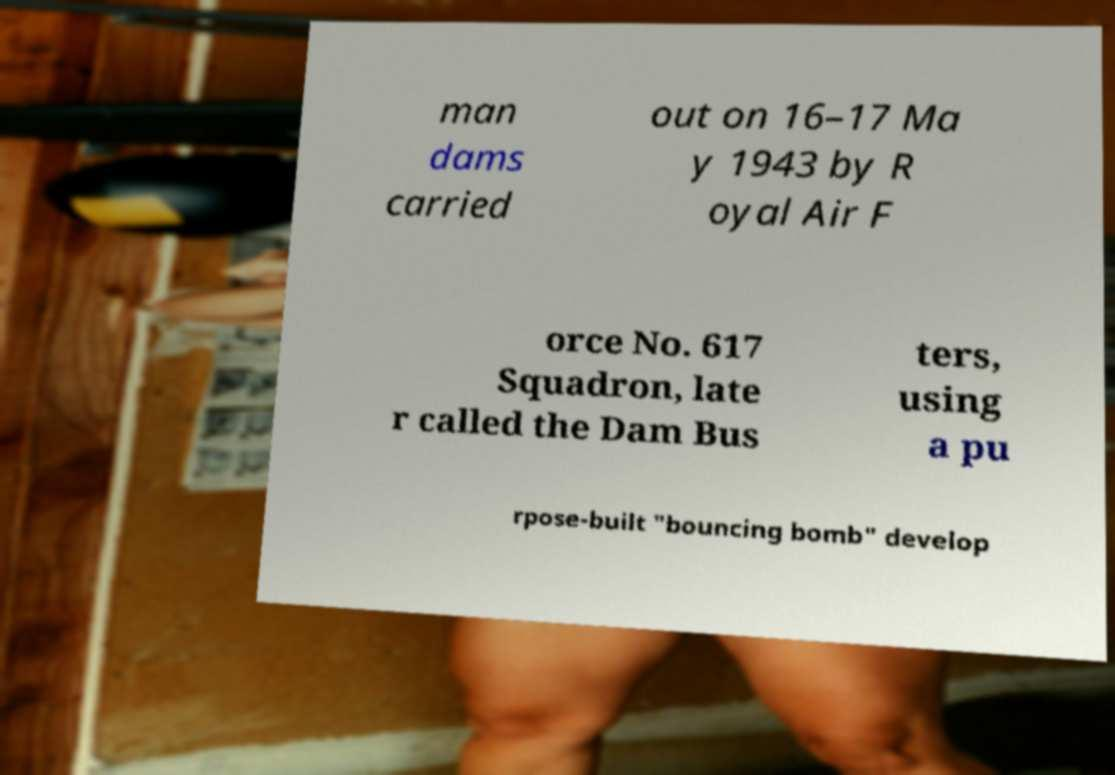Please read and relay the text visible in this image. What does it say? man dams carried out on 16–17 Ma y 1943 by R oyal Air F orce No. 617 Squadron, late r called the Dam Bus ters, using a pu rpose-built "bouncing bomb" develop 